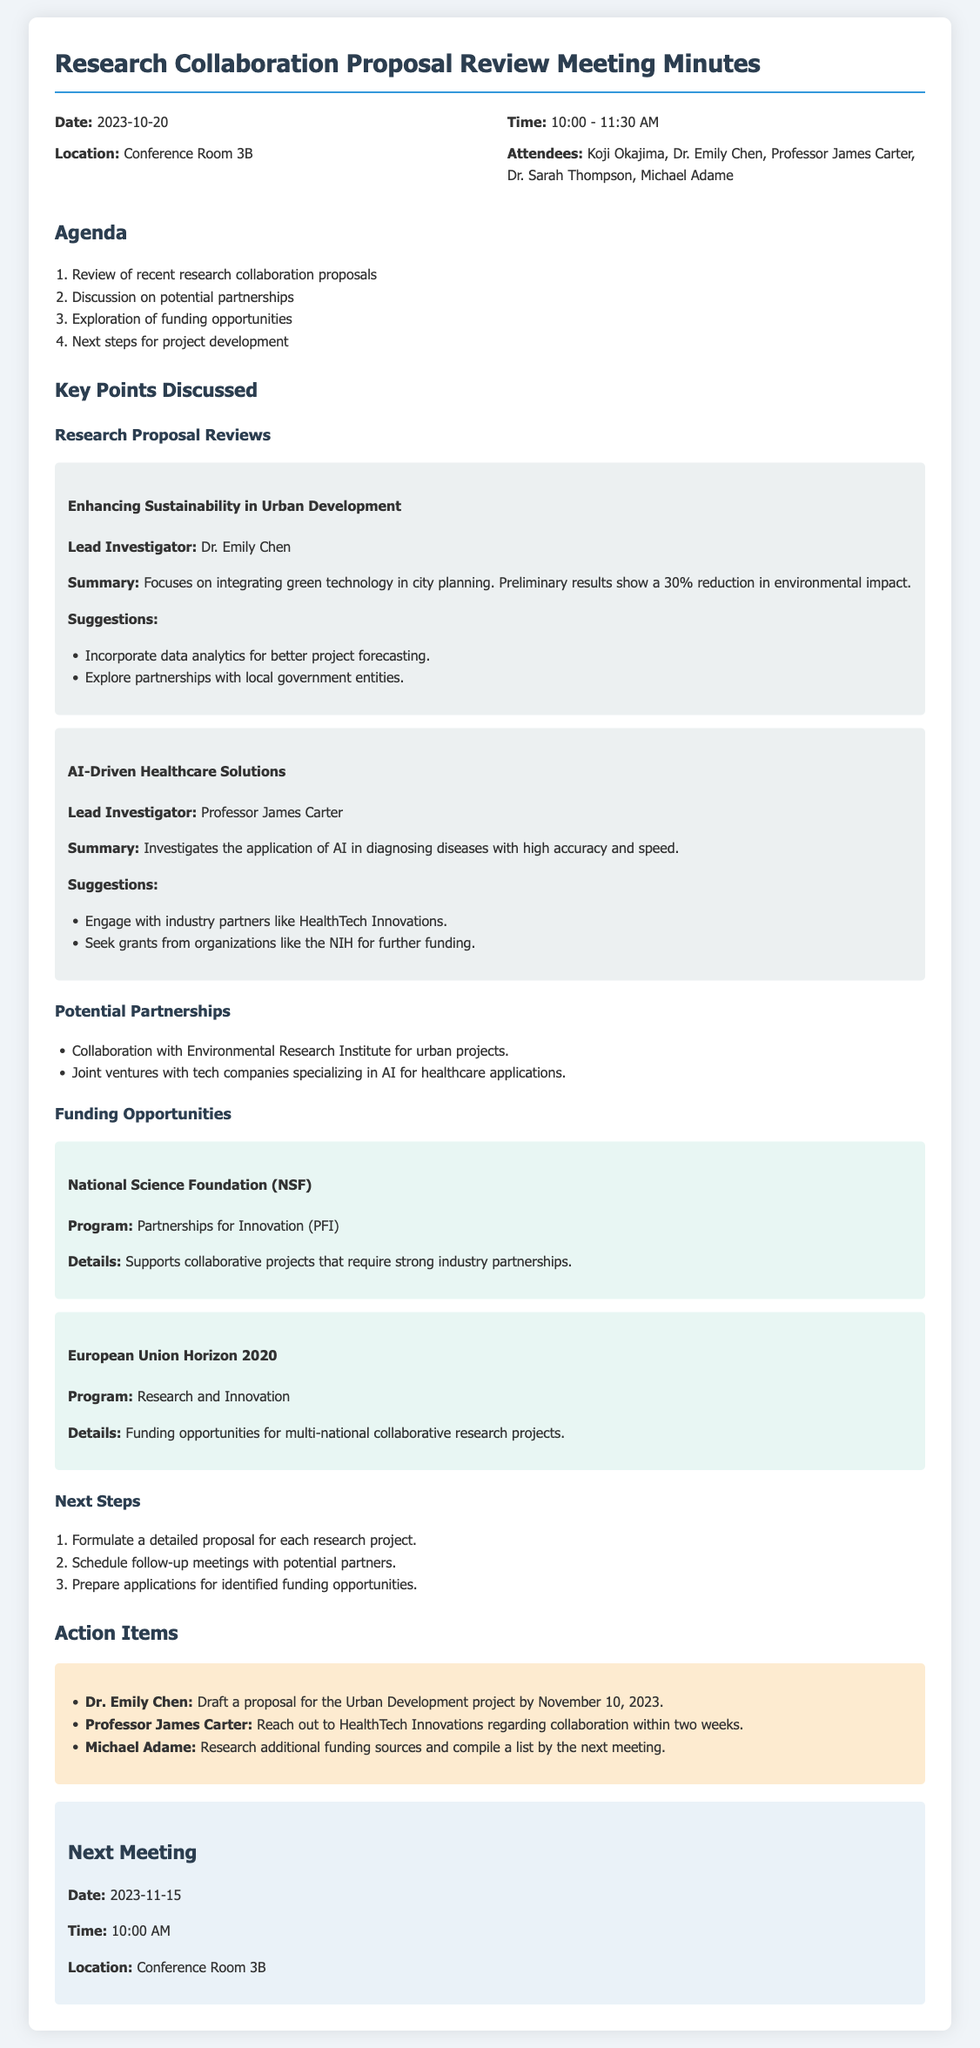What is the date of the meeting? The date of the meeting is stated in the header information of the document.
Answer: 2023-10-20 Who is the lead investigator for the AI-Driven Healthcare Solutions proposal? The lead investigator is specified in the section discussing the research proposal reviews.
Answer: Professor James Carter What is the program offered by the National Science Foundation? The program details can be found in the Funding Opportunities section of the document.
Answer: Partnerships for Innovation (PFI) Which project focuses on urban development? The projects mentioned in the research proposal reviews section include specific titles.
Answer: Enhancing Sustainability in Urban Development What is the next meeting's date? The next meeting date is mentioned toward the end of the document.
Answer: 2023-11-15 What was suggested for the Urban Development project? Suggestions for the proposal are listed under that specific project's discussion.
Answer: Incorporate data analytics for better project forecasting Which funding opportunity is associated with multi-national collaborative research projects? Funding opportunities for multi-national projects are detailed in the document.
Answer: European Union Horizon 2020 Who is tasked with reaching out to HealthTech Innovations? The action items specify responsibilities assigned to attendees.
Answer: Professor James Carter 